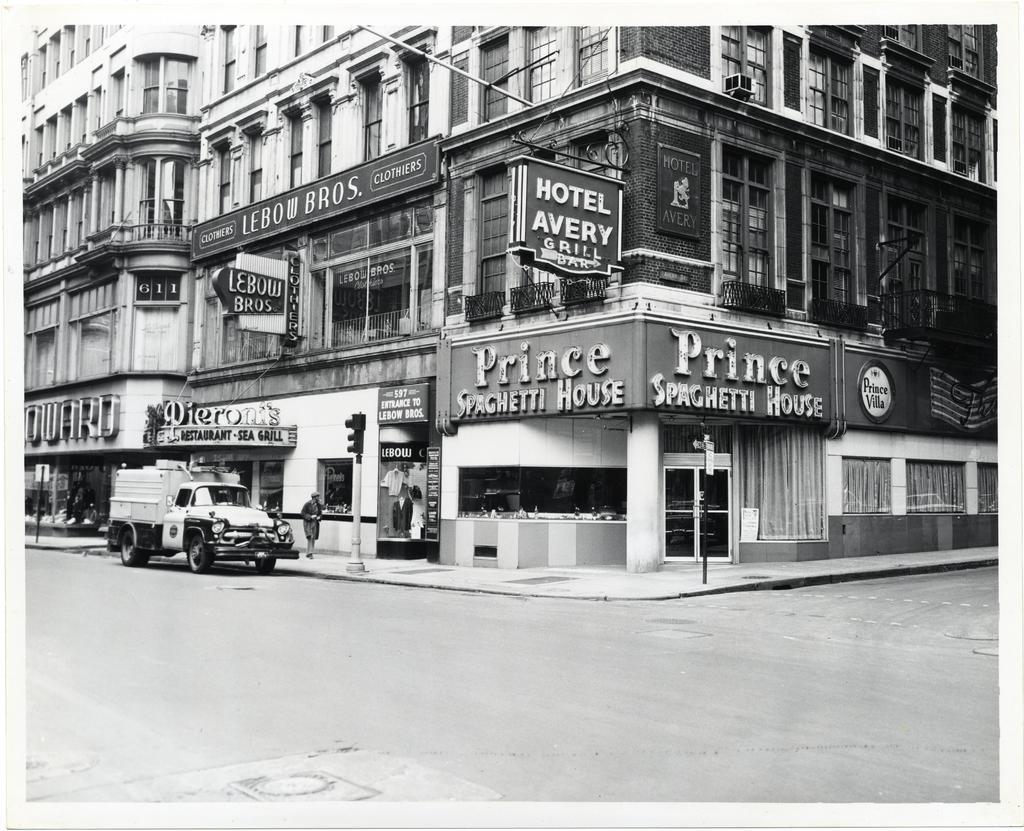What is located in the center of the image? There are buildings in the center of the image. What can be seen on the boards in the image? The facts do not specify what is visible on the boards, so we cannot answer this question definitively. What is at the bottom of the image? There is a road at the bottom of the image. What is on the left side of the image? There is a vehicle on the left side of the image. Who is the owner of the vehicle in the image? The facts do not provide any information about the vehicle's owner, so we cannot answer this question definitively. What type of pollution is visible in the image? The facts do not mention any pollution in the image, so we cannot answer this question definitively. 